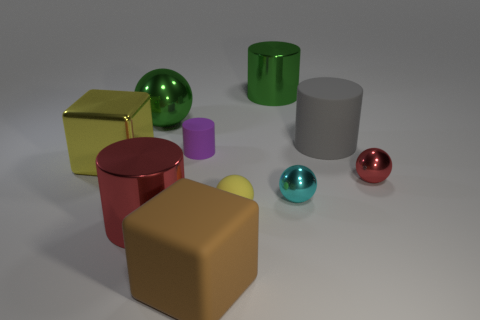How many big things are gray things or brown matte blocks?
Provide a succinct answer. 2. How many things are metallic balls that are behind the small cyan shiny sphere or tiny things that are to the left of the tiny yellow rubber thing?
Your answer should be compact. 3. Is the number of tiny cyan shiny balls less than the number of small cyan matte things?
Your answer should be very brief. No. The red metal thing that is the same size as the purple rubber object is what shape?
Provide a succinct answer. Sphere. What number of other things are there of the same color as the big matte cylinder?
Give a very brief answer. 0. How many tiny cylinders are there?
Your answer should be compact. 1. What number of tiny rubber things are behind the tiny cyan metallic thing and to the right of the purple cylinder?
Offer a terse response. 0. What is the material of the big sphere?
Your answer should be very brief. Metal. Are there any large brown rubber blocks?
Your answer should be very brief. Yes. There is a big matte thing behind the big red metal object; what color is it?
Offer a terse response. Gray. 